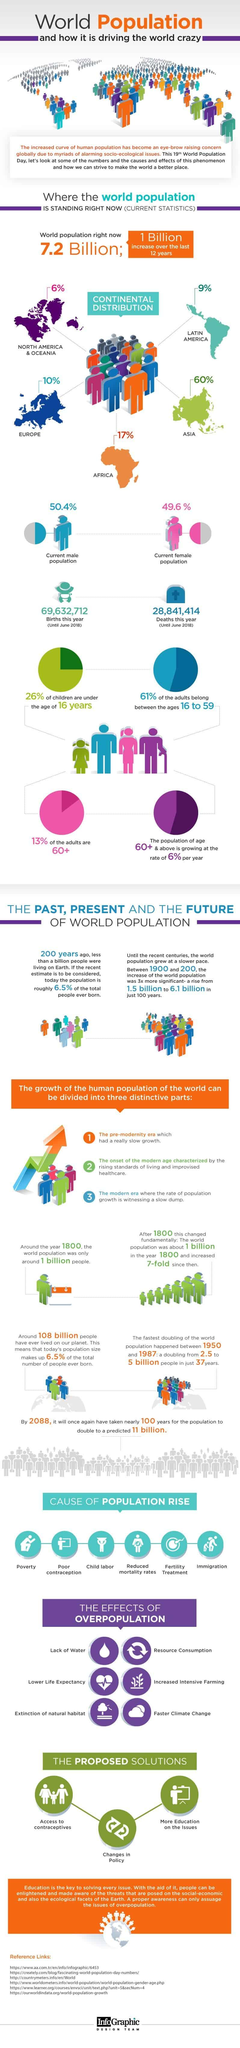Specify some key components in this picture. North America and Oceania are the least populated continents in the world. According to recent estimates, approximately 87% of the adult population in the world is below the age of 60. As of June 2018, the total number of births this year was 69,632,712. Asia is the most densely populated continent in the world. Approximately 50.4% of the world's population is male. 